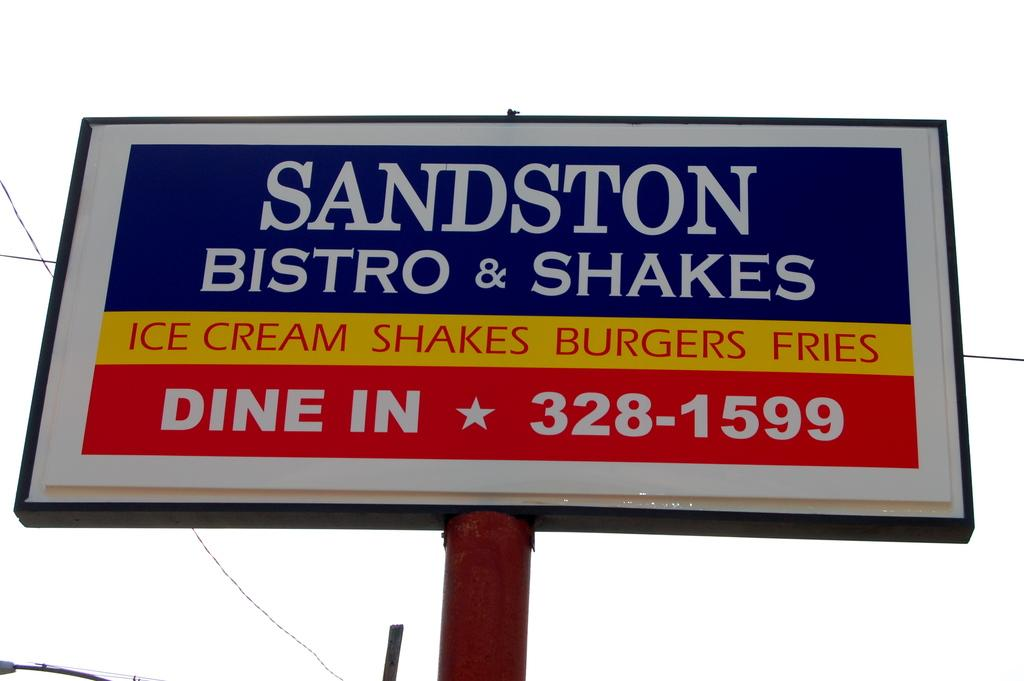<image>
Provide a brief description of the given image. a dine in sign that is above the ground 